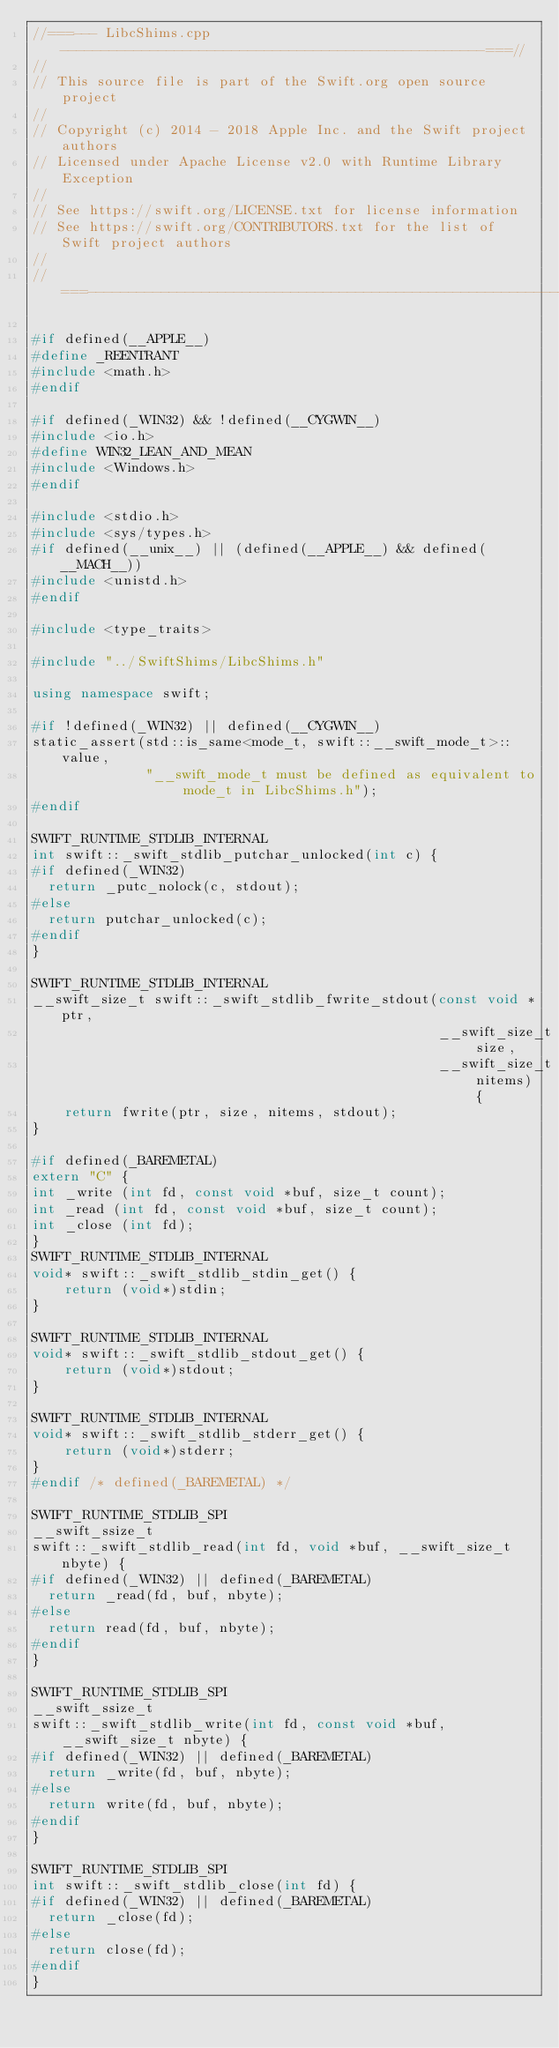Convert code to text. <code><loc_0><loc_0><loc_500><loc_500><_C++_>//===--- LibcShims.cpp ----------------------------------------------------===//
//
// This source file is part of the Swift.org open source project
//
// Copyright (c) 2014 - 2018 Apple Inc. and the Swift project authors
// Licensed under Apache License v2.0 with Runtime Library Exception
//
// See https://swift.org/LICENSE.txt for license information
// See https://swift.org/CONTRIBUTORS.txt for the list of Swift project authors
//
//===----------------------------------------------------------------------===//

#if defined(__APPLE__)
#define _REENTRANT
#include <math.h>
#endif

#if defined(_WIN32) && !defined(__CYGWIN__)
#include <io.h>
#define WIN32_LEAN_AND_MEAN
#include <Windows.h>
#endif

#include <stdio.h>
#include <sys/types.h>
#if defined(__unix__) || (defined(__APPLE__) && defined(__MACH__))
#include <unistd.h>
#endif

#include <type_traits>

#include "../SwiftShims/LibcShims.h"

using namespace swift;

#if !defined(_WIN32) || defined(__CYGWIN__)
static_assert(std::is_same<mode_t, swift::__swift_mode_t>::value,
              "__swift_mode_t must be defined as equivalent to mode_t in LibcShims.h");
#endif

SWIFT_RUNTIME_STDLIB_INTERNAL
int swift::_swift_stdlib_putchar_unlocked(int c) {
#if defined(_WIN32)
  return _putc_nolock(c, stdout);
#else
  return putchar_unlocked(c);
#endif
}

SWIFT_RUNTIME_STDLIB_INTERNAL
__swift_size_t swift::_swift_stdlib_fwrite_stdout(const void *ptr,
                                                  __swift_size_t size,
                                                  __swift_size_t nitems) {
    return fwrite(ptr, size, nitems, stdout);
}

#if defined(_BAREMETAL)
extern "C" {
int _write (int fd, const void *buf, size_t count);
int _read (int fd, const void *buf, size_t count);
int _close (int fd);
}
SWIFT_RUNTIME_STDLIB_INTERNAL
void* swift::_swift_stdlib_stdin_get() {
    return (void*)stdin;
}

SWIFT_RUNTIME_STDLIB_INTERNAL
void* swift::_swift_stdlib_stdout_get() {
    return (void*)stdout;
}

SWIFT_RUNTIME_STDLIB_INTERNAL
void* swift::_swift_stdlib_stderr_get() {
    return (void*)stderr;
}
#endif /* defined(_BAREMETAL) */

SWIFT_RUNTIME_STDLIB_SPI
__swift_ssize_t
swift::_swift_stdlib_read(int fd, void *buf, __swift_size_t nbyte) {
#if defined(_WIN32) || defined(_BAREMETAL)
  return _read(fd, buf, nbyte);
#else
  return read(fd, buf, nbyte);
#endif
}

SWIFT_RUNTIME_STDLIB_SPI
__swift_ssize_t
swift::_swift_stdlib_write(int fd, const void *buf, __swift_size_t nbyte) {
#if defined(_WIN32) || defined(_BAREMETAL)
  return _write(fd, buf, nbyte);
#else
  return write(fd, buf, nbyte);
#endif
}

SWIFT_RUNTIME_STDLIB_SPI
int swift::_swift_stdlib_close(int fd) {
#if defined(_WIN32) || defined(_BAREMETAL)
  return _close(fd);
#else
  return close(fd);
#endif
}
</code> 